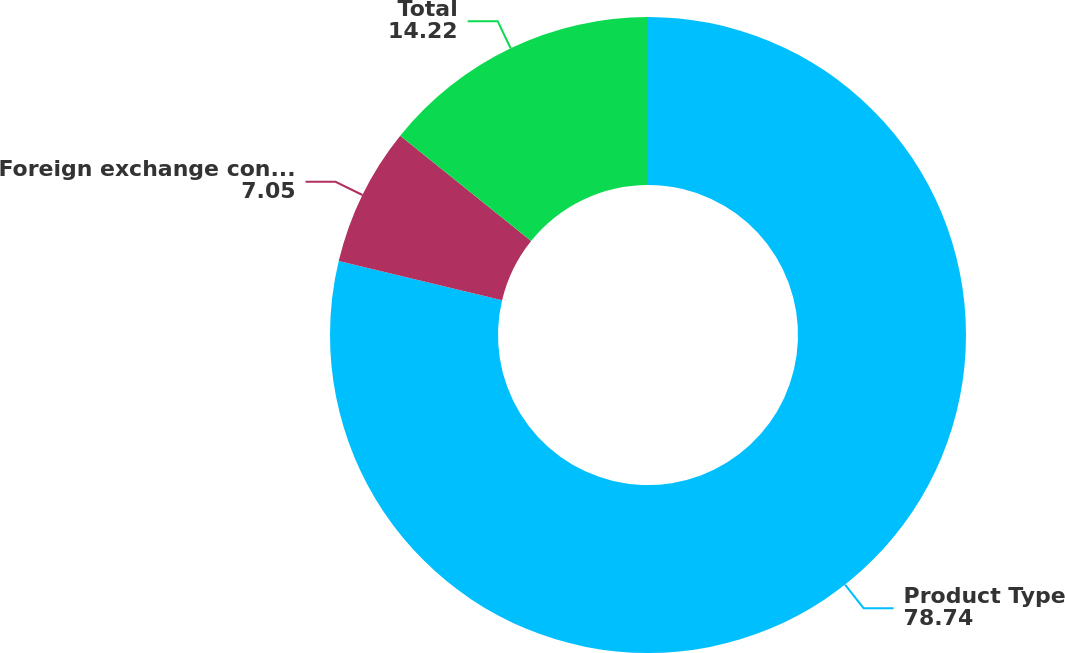Convert chart. <chart><loc_0><loc_0><loc_500><loc_500><pie_chart><fcel>Product Type<fcel>Foreign exchange contracts(2)<fcel>Total<nl><fcel>78.74%<fcel>7.05%<fcel>14.22%<nl></chart> 